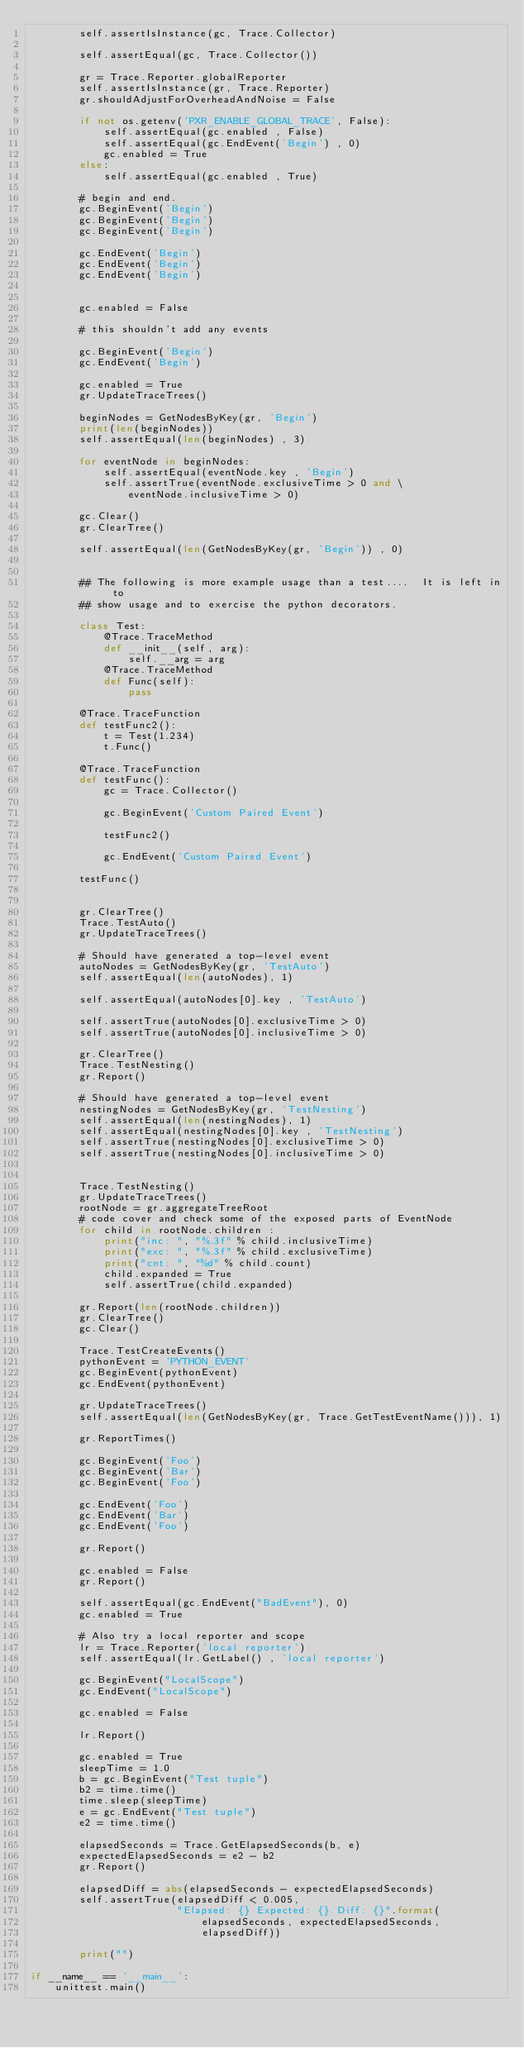<code> <loc_0><loc_0><loc_500><loc_500><_Python_>        self.assertIsInstance(gc, Trace.Collector)

        self.assertEqual(gc, Trace.Collector())

        gr = Trace.Reporter.globalReporter
        self.assertIsInstance(gr, Trace.Reporter)
        gr.shouldAdjustForOverheadAndNoise = False

        if not os.getenv('PXR_ENABLE_GLOBAL_TRACE', False):
            self.assertEqual(gc.enabled , False)
            self.assertEqual(gc.EndEvent('Begin') , 0)
            gc.enabled = True
        else:
            self.assertEqual(gc.enabled , True)

        # begin and end.
        gc.BeginEvent('Begin')
        gc.BeginEvent('Begin')
        gc.BeginEvent('Begin')

        gc.EndEvent('Begin')
        gc.EndEvent('Begin')
        gc.EndEvent('Begin')


        gc.enabled = False

        # this shouldn't add any events

        gc.BeginEvent('Begin')
        gc.EndEvent('Begin')

        gc.enabled = True
        gr.UpdateTraceTrees()

        beginNodes = GetNodesByKey(gr, 'Begin')
        print(len(beginNodes))
        self.assertEqual(len(beginNodes) , 3)

        for eventNode in beginNodes:
            self.assertEqual(eventNode.key , 'Begin')
            self.assertTrue(eventNode.exclusiveTime > 0 and \
                eventNode.inclusiveTime > 0)

        gc.Clear()
        gr.ClearTree()

        self.assertEqual(len(GetNodesByKey(gr, 'Begin')) , 0)


        ## The following is more example usage than a test....  It is left in to
        ## show usage and to exercise the python decorators.

        class Test:
            @Trace.TraceMethod
            def __init__(self, arg):
                self.__arg = arg
            @Trace.TraceMethod
            def Func(self):
                pass

        @Trace.TraceFunction
        def testFunc2():
            t = Test(1.234)
            t.Func()

        @Trace.TraceFunction
        def testFunc():
            gc = Trace.Collector()

            gc.BeginEvent('Custom Paired Event')

            testFunc2()
                
            gc.EndEvent('Custom Paired Event')

        testFunc()


        gr.ClearTree()
        Trace.TestAuto()
        gr.UpdateTraceTrees()

        # Should have generated a top-level event
        autoNodes = GetNodesByKey(gr, 'TestAuto')
        self.assertEqual(len(autoNodes), 1)

        self.assertEqual(autoNodes[0].key , 'TestAuto')

        self.assertTrue(autoNodes[0].exclusiveTime > 0)
        self.assertTrue(autoNodes[0].inclusiveTime > 0)

        gr.ClearTree()
        Trace.TestNesting()
        gr.Report()

        # Should have generated a top-level event
        nestingNodes = GetNodesByKey(gr, 'TestNesting')
        self.assertEqual(len(nestingNodes), 1)
        self.assertEqual(nestingNodes[0].key , 'TestNesting')
        self.assertTrue(nestingNodes[0].exclusiveTime > 0)
        self.assertTrue(nestingNodes[0].inclusiveTime > 0)


        Trace.TestNesting()
        gr.UpdateTraceTrees()
        rootNode = gr.aggregateTreeRoot
        # code cover and check some of the exposed parts of EventNode
        for child in rootNode.children :
            print("inc: ", "%.3f" % child.inclusiveTime) 
            print("exc: ", "%.3f" % child.exclusiveTime)
            print("cnt: ", "%d" % child.count)
            child.expanded = True
            self.assertTrue(child.expanded)
            
        gr.Report(len(rootNode.children))
        gr.ClearTree()
        gc.Clear()

        Trace.TestCreateEvents()
        pythonEvent = 'PYTHON_EVENT'
        gc.BeginEvent(pythonEvent)
        gc.EndEvent(pythonEvent)

        gr.UpdateTraceTrees()
        self.assertEqual(len(GetNodesByKey(gr, Trace.GetTestEventName())), 1)

        gr.ReportTimes()

        gc.BeginEvent('Foo')
        gc.BeginEvent('Bar')
        gc.BeginEvent('Foo')

        gc.EndEvent('Foo')
        gc.EndEvent('Bar')
        gc.EndEvent('Foo')

        gr.Report()

        gc.enabled = False
        gr.Report()

        self.assertEqual(gc.EndEvent("BadEvent"), 0)
        gc.enabled = True

        # Also try a local reporter and scope
        lr = Trace.Reporter('local reporter')
        self.assertEqual(lr.GetLabel() , 'local reporter')

        gc.BeginEvent("LocalScope")
        gc.EndEvent("LocalScope")

        gc.enabled = False

        lr.Report()

        gc.enabled = True
        sleepTime = 1.0
        b = gc.BeginEvent("Test tuple")
        b2 = time.time()
        time.sleep(sleepTime)
        e = gc.EndEvent("Test tuple")
        e2 = time.time()

        elapsedSeconds = Trace.GetElapsedSeconds(b, e)
        expectedElapsedSeconds = e2 - b2
        gr.Report()

        elapsedDiff = abs(elapsedSeconds - expectedElapsedSeconds)
        self.assertTrue(elapsedDiff < 0.005,
                        "Elapsed: {} Expected: {} Diff: {}".format(
                            elapsedSeconds, expectedElapsedSeconds, 
                            elapsedDiff))

        print("")

if __name__ == '__main__':
    unittest.main()

</code> 